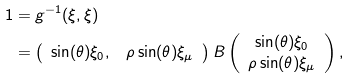Convert formula to latex. <formula><loc_0><loc_0><loc_500><loc_500>1 & = g ^ { - 1 } ( \xi , \xi ) \\ & = \left ( \begin{array} { c c } \sin ( \theta ) \xi _ { 0 } , & \rho \sin ( \theta ) \xi _ { \mu } \end{array} \right ) B \left ( \begin{array} { c } \sin ( \theta ) \xi _ { 0 } \\ \rho \sin ( \theta ) \xi _ { \mu } \end{array} \right ) ,</formula> 